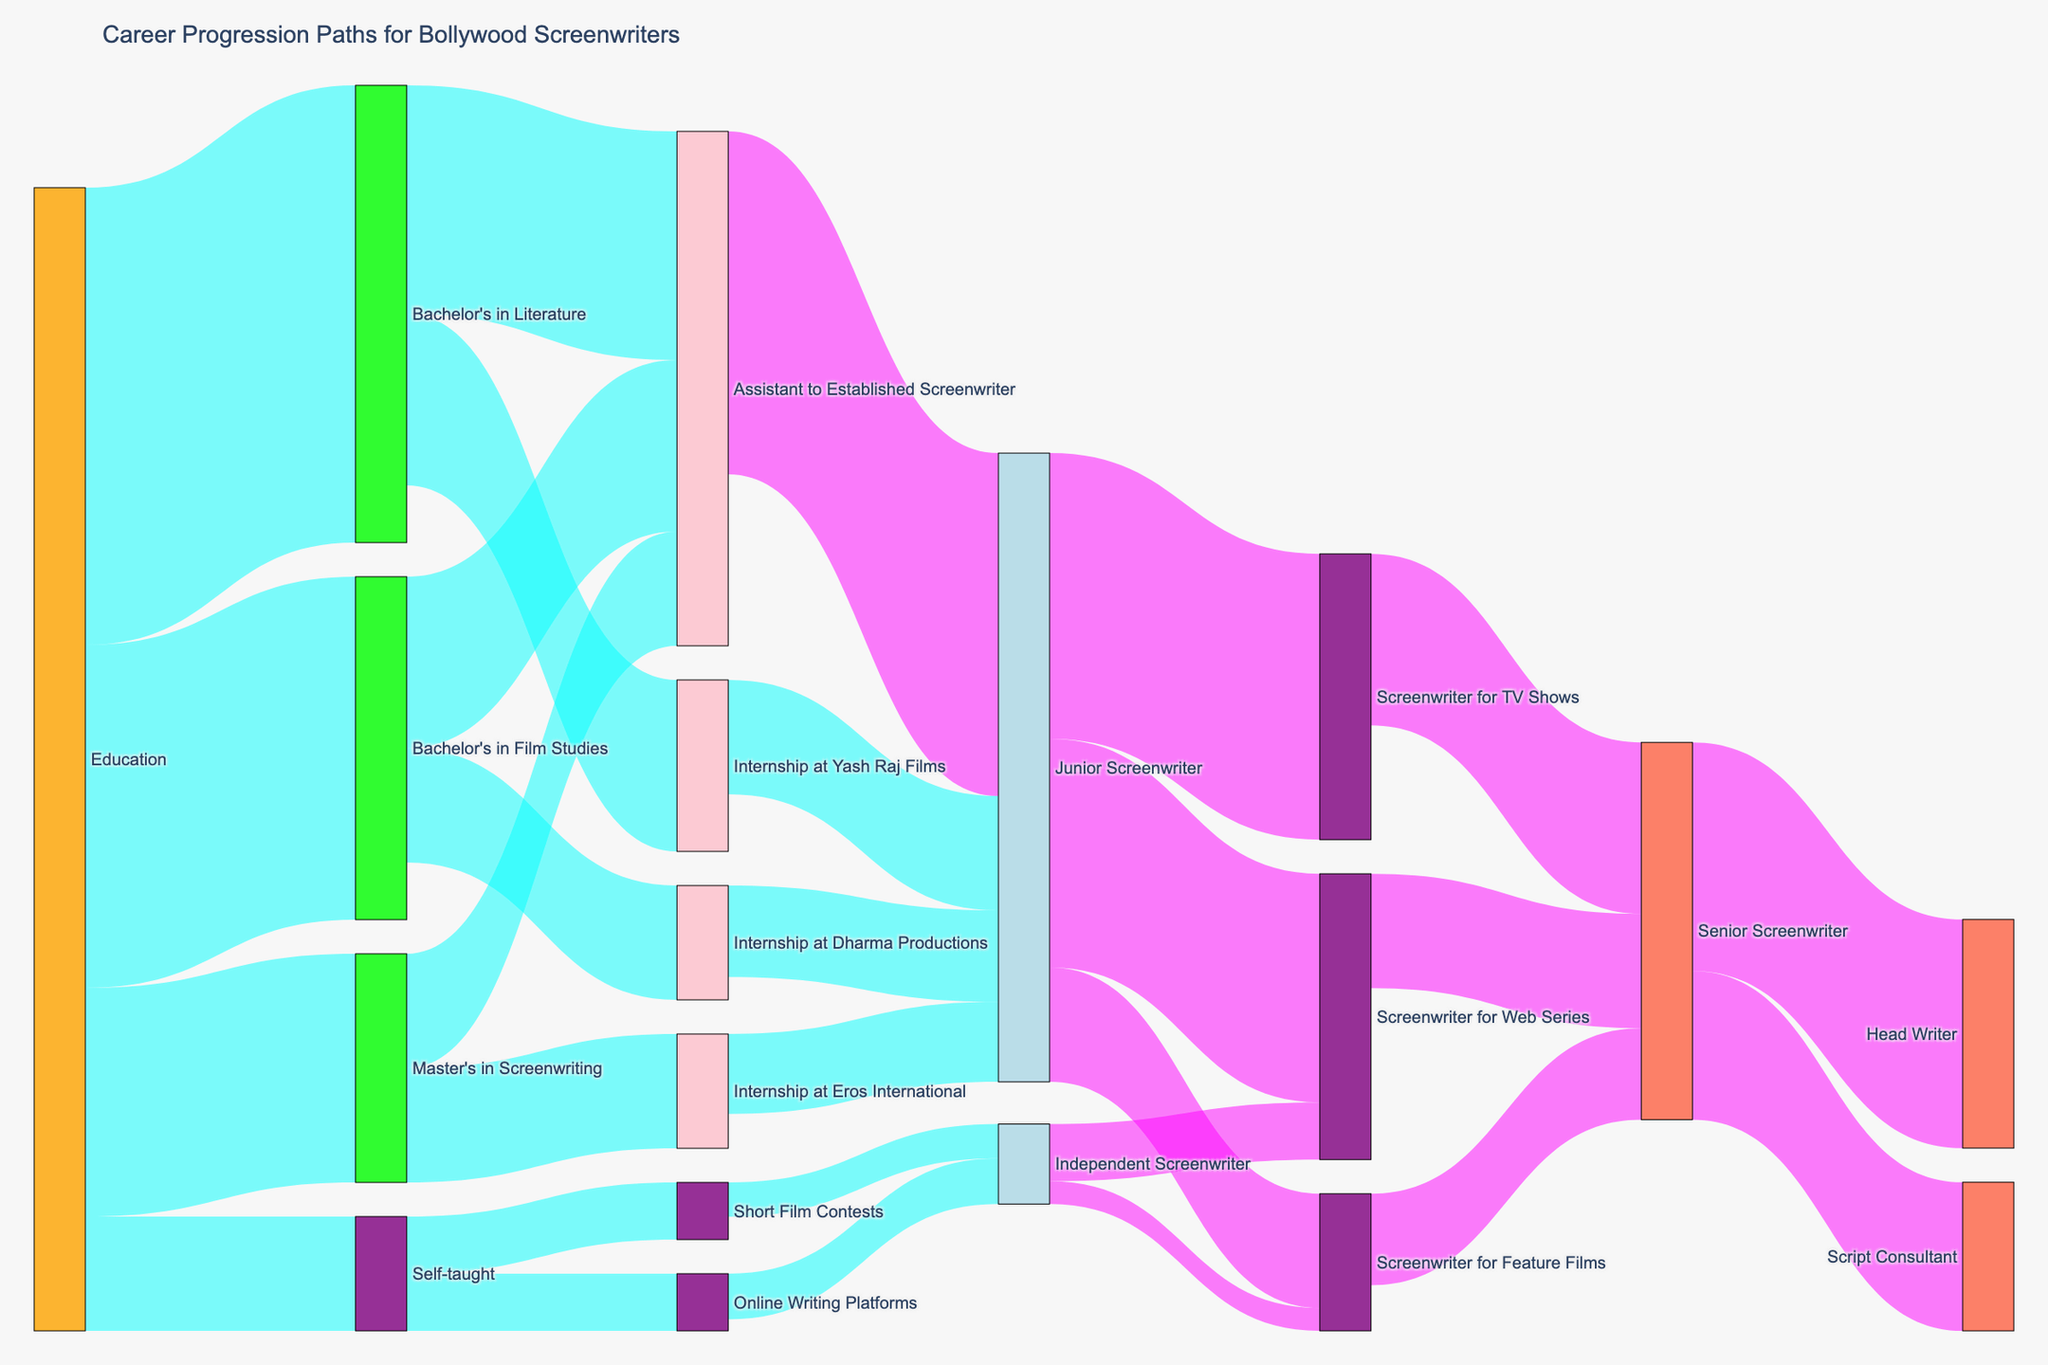What is the most common educational background for aspiring Bollywood screenwriters in this diagram? The bars for "Bachelor's in Literature" originating from "Education" are the tallest, indicating it has the highest value.
Answer: Bachelor's in Literature What are the top two paths after completing a Bachelor's in Film Studies? The Sankey diagram shows "Internship at Dharma Productions" and "Assistant to Established Screenwriter" as the paths originating from "Bachelor's in Film Studies." Both have similar values but "Assistant to Established Screenwriter" slightly more.
Answer: Assistant to Established Screenwriter, Internship at Dharma Productions How many people move from internships to becoming Junior Screenwriters? Summing up the values from "Internship at Yash Raj Films," "Internship at Dharma Productions," and "Internship at Eros International" to "Junior Screenwriter." The total is 10+8+7.
Answer: 25 Which career path ultimately leads the most people to become Senior Screenwriters? Following the flows, most paths converge from "Junior Screenwriter" to "Screenwriter for TV Shows" which eventually leads to a higher number of "Senior Screenwriter" flows.
Answer: Screenwriter for TV Shows What proportion of self-taught screenwriters end up as Screenwriters for Feature Films? The flows from "Self-taught" to "Independent Screenwriter," then to "Screenwriter for Feature Films," needs to be followed. Out of 10 self-taught individuals, 2 become screenwriters for feature films, making the proportion 2/10.
Answer: 20% How many career paths lead to becoming a Head Writer? Check the "Senior Screenwriter" node, which has one flow leading to "Head Writer."
Answer: 1 Compare the chances of becoming a Junior Screenwriter from a Master's in Screenwriting versus a Bachelor's in Literature. From "Master's in Screenwriting," 10 people become Junior Screenwriters; from "Bachelor's in Literature," combining both internships 15+20 goes to Junior Screenwriter. Therefore, Master's has 10, and Bachelor's literature has higher combined.
Answer: Bachelor's in Literature leads to more Junior Screenwriters Which educational background has the least direct path to becoming a Senior Screenwriter? Starting from the educational background, "Self-taught" has the least direct flow to higher levels compared to formal education paths.
Answer: Self-taught What is the next most common career step after being a Senior Screenwriter? The "Senior Screenwriter" node has two significant flows leading to "Head Writer" and "Script Consultant." Among these, the "Head Writer" seems to have a larger value flow.
Answer: Head Writer Explain whether entering the industry through internships is more common than through being an Assistant to an Established Screenwriter. Compare total values originating from "Internships" (Yash Raj, Dharma, Eros) and "Assistant to Established Screenwriter." The total for "Internships" is 15+10+10 = 35, and the total for "Assistant to Established Screenwriter" is higher when adding up all values.
Answer: Assistant to Established Screenwriter 